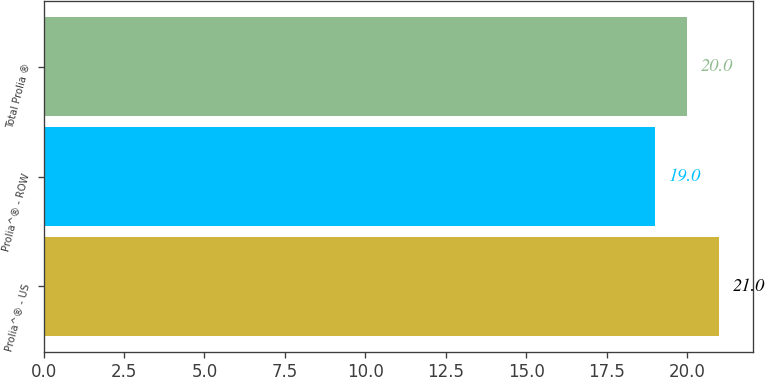Convert chart to OTSL. <chart><loc_0><loc_0><loc_500><loc_500><bar_chart><fcel>Prolia^® - US<fcel>Prolia^® - ROW<fcel>Total Prolia ®<nl><fcel>21<fcel>19<fcel>20<nl></chart> 